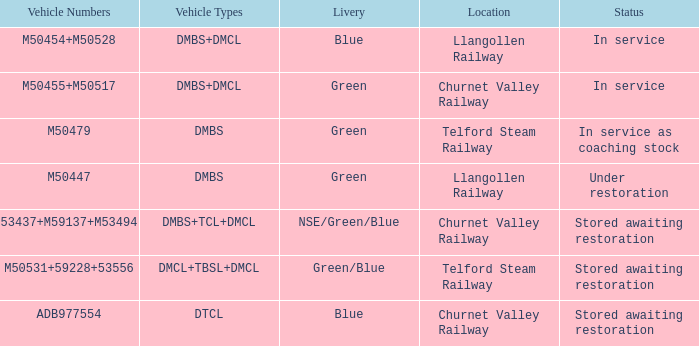What livery has a status of in service as coaching stock? Green. 